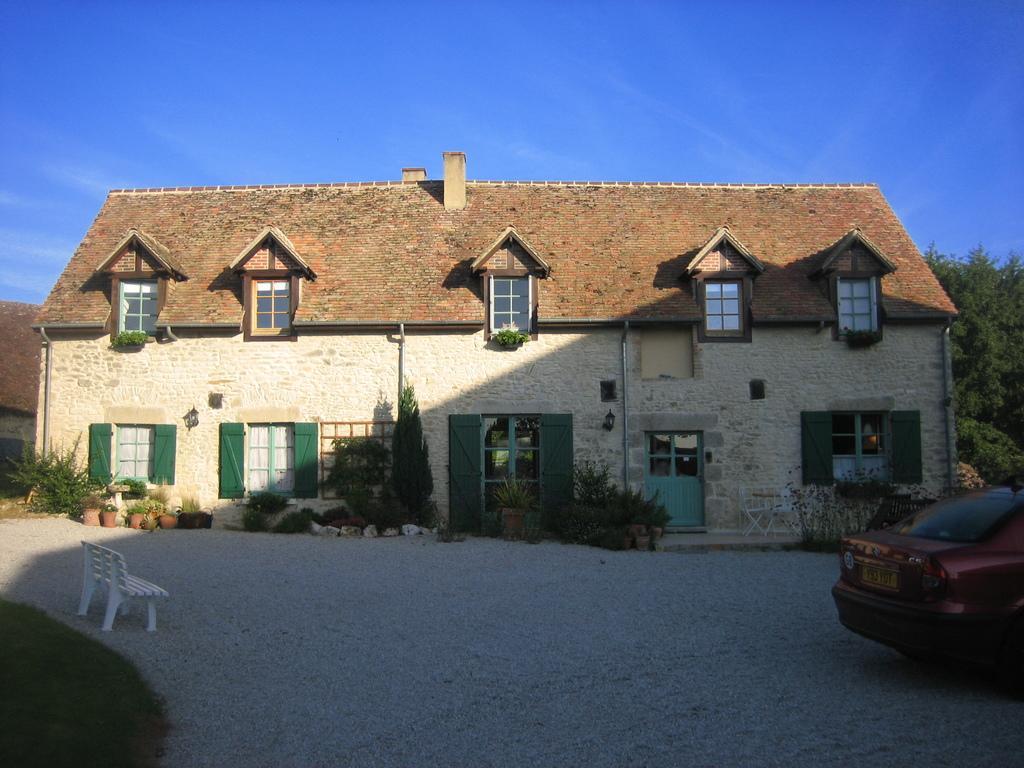How would you summarize this image in a sentence or two? In this image I can see a house made up of rocks in the center of the image. I can see doors and windows of the house and some potted plants. I can see a wooden bench on the left hand side of the image. I can see trees behind the house. At the top of the image I can see the sky in the right bottom corner I can see a car. 